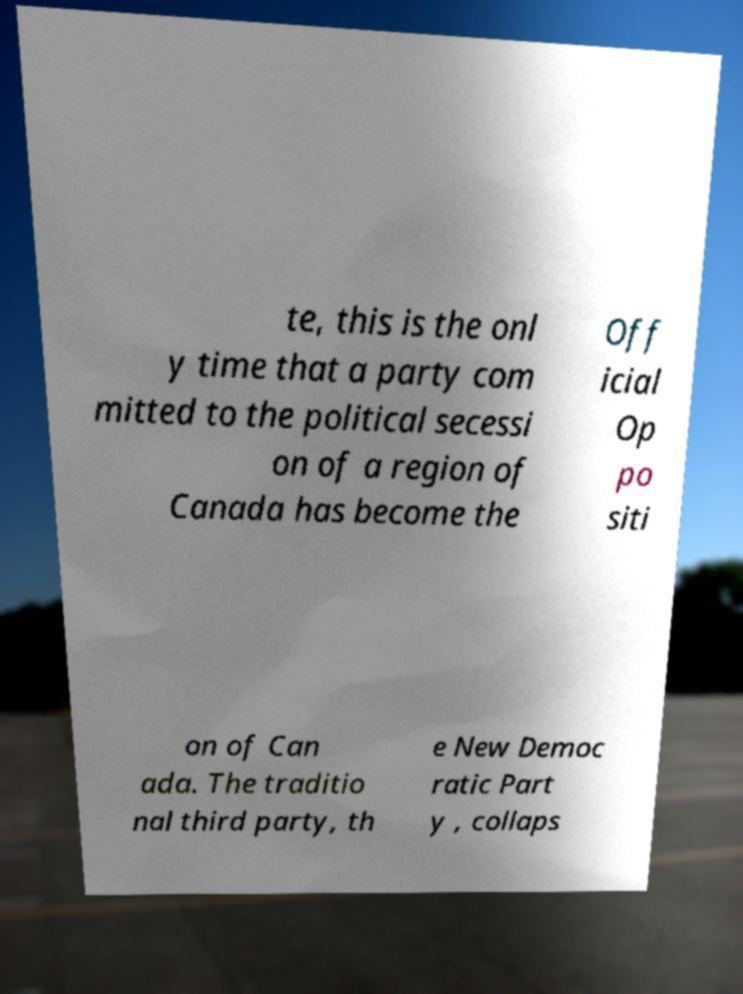Please read and relay the text visible in this image. What does it say? te, this is the onl y time that a party com mitted to the political secessi on of a region of Canada has become the Off icial Op po siti on of Can ada. The traditio nal third party, th e New Democ ratic Part y , collaps 